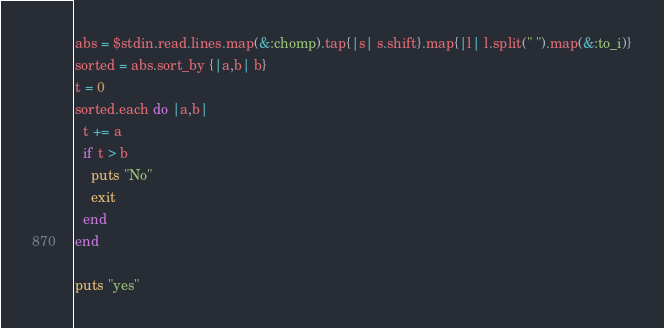Convert code to text. <code><loc_0><loc_0><loc_500><loc_500><_Ruby_>abs = $stdin.read.lines.map(&:chomp).tap{|s| s.shift}.map{|l| l.split(" ").map(&:to_i)}
sorted = abs.sort_by {|a,b| b}
t = 0
sorted.each do |a,b|
  t += a
  if t > b
    puts "No"
    exit
  end
end

puts "yes"
</code> 